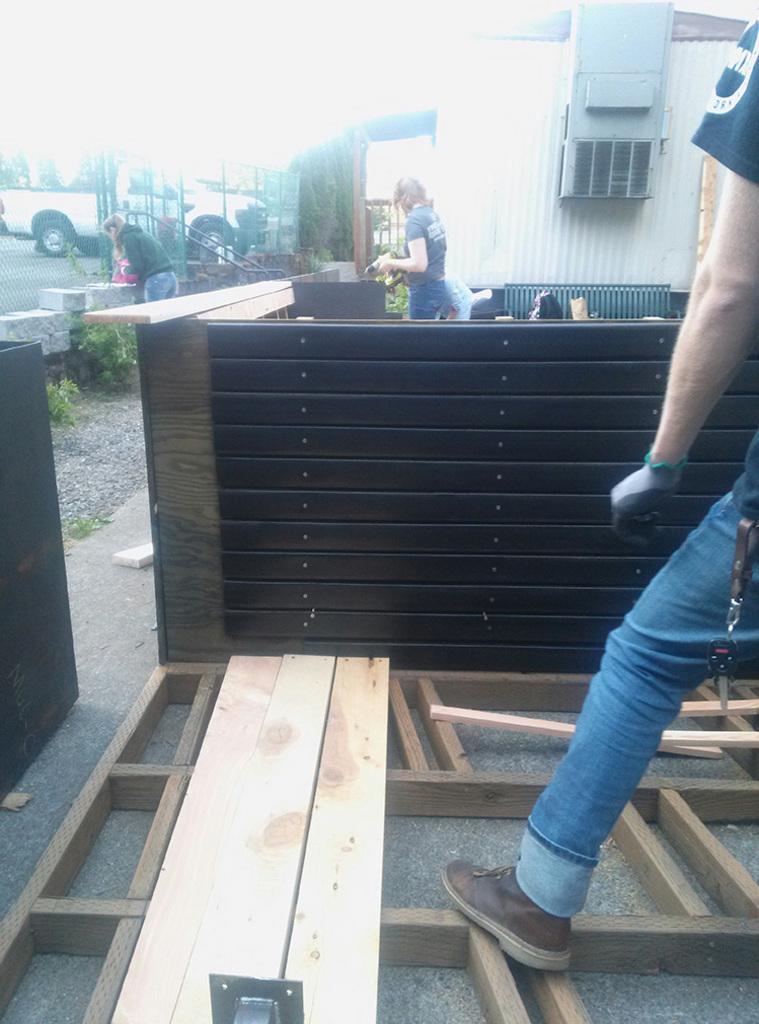In one or two sentences, can you explain what this image depicts? There is some wood work going on in the picture and a person is standing on the wooden sticks, behind him there is a wooden house and few people were sitting in the area in front of the house, on the left side there is another person and in the background there is a truck. 